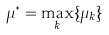<formula> <loc_0><loc_0><loc_500><loc_500>\mu ^ { * } = \max _ { k } \{ \mu _ { k } \}</formula> 